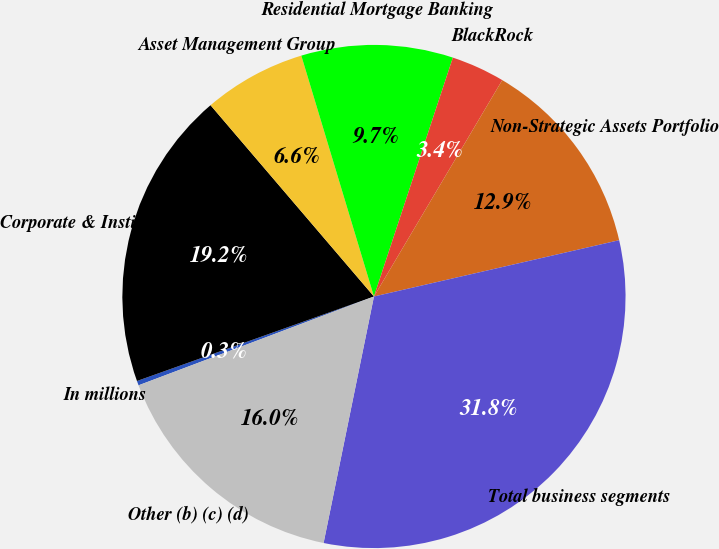Convert chart to OTSL. <chart><loc_0><loc_0><loc_500><loc_500><pie_chart><fcel>In millions<fcel>Corporate & Institutional<fcel>Asset Management Group<fcel>Residential Mortgage Banking<fcel>BlackRock<fcel>Non-Strategic Assets Portfolio<fcel>Total business segments<fcel>Other (b) (c) (d)<nl><fcel>0.29%<fcel>19.2%<fcel>6.59%<fcel>9.74%<fcel>3.44%<fcel>12.89%<fcel>31.8%<fcel>16.05%<nl></chart> 